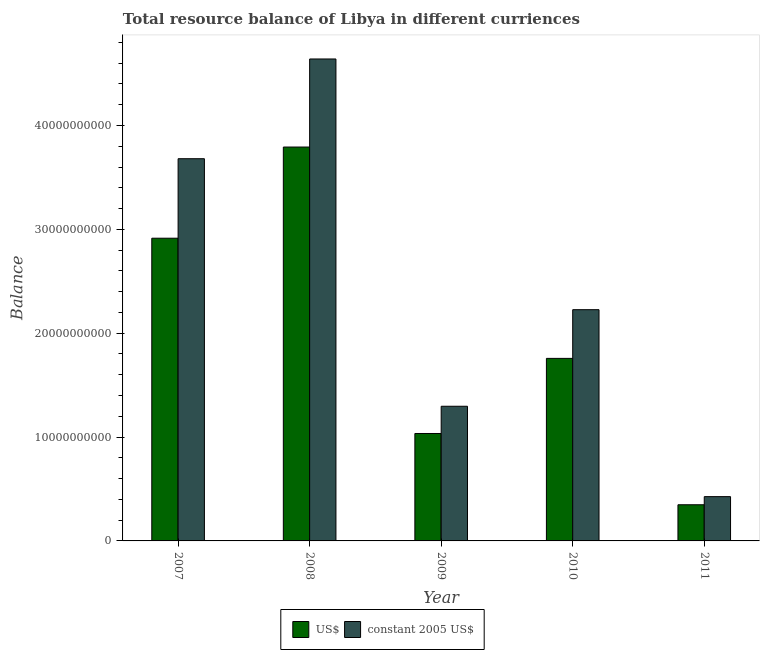How many groups of bars are there?
Offer a terse response. 5. Are the number of bars per tick equal to the number of legend labels?
Your answer should be very brief. Yes. Are the number of bars on each tick of the X-axis equal?
Offer a very short reply. Yes. What is the label of the 1st group of bars from the left?
Ensure brevity in your answer.  2007. What is the resource balance in us$ in 2010?
Offer a terse response. 1.76e+1. Across all years, what is the maximum resource balance in constant us$?
Make the answer very short. 4.64e+1. Across all years, what is the minimum resource balance in us$?
Give a very brief answer. 3.48e+09. In which year was the resource balance in us$ minimum?
Keep it short and to the point. 2011. What is the total resource balance in constant us$ in the graph?
Your answer should be compact. 1.23e+11. What is the difference between the resource balance in us$ in 2010 and that in 2011?
Provide a short and direct response. 1.41e+1. What is the difference between the resource balance in constant us$ in 2009 and the resource balance in us$ in 2008?
Offer a very short reply. -3.34e+1. What is the average resource balance in constant us$ per year?
Your answer should be compact. 2.45e+1. In the year 2008, what is the difference between the resource balance in constant us$ and resource balance in us$?
Your answer should be very brief. 0. In how many years, is the resource balance in constant us$ greater than 22000000000 units?
Offer a very short reply. 3. What is the ratio of the resource balance in constant us$ in 2009 to that in 2010?
Make the answer very short. 0.58. Is the resource balance in us$ in 2008 less than that in 2011?
Your answer should be very brief. No. Is the difference between the resource balance in constant us$ in 2007 and 2009 greater than the difference between the resource balance in us$ in 2007 and 2009?
Your answer should be very brief. No. What is the difference between the highest and the second highest resource balance in us$?
Keep it short and to the point. 8.78e+09. What is the difference between the highest and the lowest resource balance in us$?
Your answer should be very brief. 3.44e+1. What does the 1st bar from the left in 2007 represents?
Offer a very short reply. US$. What does the 1st bar from the right in 2010 represents?
Your answer should be very brief. Constant 2005 us$. How many years are there in the graph?
Your response must be concise. 5. Does the graph contain any zero values?
Your response must be concise. No. Does the graph contain grids?
Keep it short and to the point. No. Where does the legend appear in the graph?
Your answer should be compact. Bottom center. How are the legend labels stacked?
Ensure brevity in your answer.  Horizontal. What is the title of the graph?
Make the answer very short. Total resource balance of Libya in different curriences. What is the label or title of the Y-axis?
Make the answer very short. Balance. What is the Balance of US$ in 2007?
Offer a very short reply. 2.91e+1. What is the Balance in constant 2005 US$ in 2007?
Make the answer very short. 3.68e+1. What is the Balance in US$ in 2008?
Offer a very short reply. 3.79e+1. What is the Balance of constant 2005 US$ in 2008?
Your answer should be compact. 4.64e+1. What is the Balance in US$ in 2009?
Your answer should be very brief. 1.03e+1. What is the Balance in constant 2005 US$ in 2009?
Ensure brevity in your answer.  1.30e+1. What is the Balance of US$ in 2010?
Ensure brevity in your answer.  1.76e+1. What is the Balance of constant 2005 US$ in 2010?
Provide a short and direct response. 2.23e+1. What is the Balance of US$ in 2011?
Ensure brevity in your answer.  3.48e+09. What is the Balance in constant 2005 US$ in 2011?
Provide a short and direct response. 4.26e+09. Across all years, what is the maximum Balance of US$?
Your response must be concise. 3.79e+1. Across all years, what is the maximum Balance of constant 2005 US$?
Your answer should be compact. 4.64e+1. Across all years, what is the minimum Balance of US$?
Your response must be concise. 3.48e+09. Across all years, what is the minimum Balance in constant 2005 US$?
Keep it short and to the point. 4.26e+09. What is the total Balance of US$ in the graph?
Ensure brevity in your answer.  9.85e+1. What is the total Balance in constant 2005 US$ in the graph?
Offer a very short reply. 1.23e+11. What is the difference between the Balance in US$ in 2007 and that in 2008?
Keep it short and to the point. -8.78e+09. What is the difference between the Balance of constant 2005 US$ in 2007 and that in 2008?
Offer a very short reply. -9.60e+09. What is the difference between the Balance in US$ in 2007 and that in 2009?
Give a very brief answer. 1.88e+1. What is the difference between the Balance of constant 2005 US$ in 2007 and that in 2009?
Provide a short and direct response. 2.38e+1. What is the difference between the Balance of US$ in 2007 and that in 2010?
Keep it short and to the point. 1.16e+1. What is the difference between the Balance of constant 2005 US$ in 2007 and that in 2010?
Your answer should be very brief. 1.45e+1. What is the difference between the Balance of US$ in 2007 and that in 2011?
Provide a succinct answer. 2.57e+1. What is the difference between the Balance of constant 2005 US$ in 2007 and that in 2011?
Give a very brief answer. 3.25e+1. What is the difference between the Balance of US$ in 2008 and that in 2009?
Provide a succinct answer. 2.76e+1. What is the difference between the Balance of constant 2005 US$ in 2008 and that in 2009?
Ensure brevity in your answer.  3.34e+1. What is the difference between the Balance of US$ in 2008 and that in 2010?
Your answer should be compact. 2.04e+1. What is the difference between the Balance in constant 2005 US$ in 2008 and that in 2010?
Your response must be concise. 2.41e+1. What is the difference between the Balance in US$ in 2008 and that in 2011?
Offer a terse response. 3.44e+1. What is the difference between the Balance of constant 2005 US$ in 2008 and that in 2011?
Give a very brief answer. 4.21e+1. What is the difference between the Balance in US$ in 2009 and that in 2010?
Provide a succinct answer. -7.23e+09. What is the difference between the Balance of constant 2005 US$ in 2009 and that in 2010?
Offer a terse response. -9.30e+09. What is the difference between the Balance of US$ in 2009 and that in 2011?
Provide a succinct answer. 6.86e+09. What is the difference between the Balance of constant 2005 US$ in 2009 and that in 2011?
Your response must be concise. 8.70e+09. What is the difference between the Balance in US$ in 2010 and that in 2011?
Your response must be concise. 1.41e+1. What is the difference between the Balance of constant 2005 US$ in 2010 and that in 2011?
Your response must be concise. 1.80e+1. What is the difference between the Balance in US$ in 2007 and the Balance in constant 2005 US$ in 2008?
Keep it short and to the point. -1.73e+1. What is the difference between the Balance of US$ in 2007 and the Balance of constant 2005 US$ in 2009?
Ensure brevity in your answer.  1.62e+1. What is the difference between the Balance of US$ in 2007 and the Balance of constant 2005 US$ in 2010?
Make the answer very short. 6.88e+09. What is the difference between the Balance of US$ in 2007 and the Balance of constant 2005 US$ in 2011?
Offer a terse response. 2.49e+1. What is the difference between the Balance in US$ in 2008 and the Balance in constant 2005 US$ in 2009?
Give a very brief answer. 2.50e+1. What is the difference between the Balance of US$ in 2008 and the Balance of constant 2005 US$ in 2010?
Give a very brief answer. 1.57e+1. What is the difference between the Balance of US$ in 2008 and the Balance of constant 2005 US$ in 2011?
Offer a terse response. 3.37e+1. What is the difference between the Balance in US$ in 2009 and the Balance in constant 2005 US$ in 2010?
Your answer should be very brief. -1.19e+1. What is the difference between the Balance in US$ in 2009 and the Balance in constant 2005 US$ in 2011?
Your response must be concise. 6.08e+09. What is the difference between the Balance of US$ in 2010 and the Balance of constant 2005 US$ in 2011?
Make the answer very short. 1.33e+1. What is the average Balance of US$ per year?
Provide a short and direct response. 1.97e+1. What is the average Balance of constant 2005 US$ per year?
Give a very brief answer. 2.45e+1. In the year 2007, what is the difference between the Balance in US$ and Balance in constant 2005 US$?
Provide a succinct answer. -7.65e+09. In the year 2008, what is the difference between the Balance of US$ and Balance of constant 2005 US$?
Provide a short and direct response. -8.48e+09. In the year 2009, what is the difference between the Balance of US$ and Balance of constant 2005 US$?
Make the answer very short. -2.62e+09. In the year 2010, what is the difference between the Balance in US$ and Balance in constant 2005 US$?
Give a very brief answer. -4.69e+09. In the year 2011, what is the difference between the Balance of US$ and Balance of constant 2005 US$?
Give a very brief answer. -7.81e+08. What is the ratio of the Balance in US$ in 2007 to that in 2008?
Your answer should be compact. 0.77. What is the ratio of the Balance in constant 2005 US$ in 2007 to that in 2008?
Offer a very short reply. 0.79. What is the ratio of the Balance of US$ in 2007 to that in 2009?
Provide a short and direct response. 2.82. What is the ratio of the Balance of constant 2005 US$ in 2007 to that in 2009?
Give a very brief answer. 2.84. What is the ratio of the Balance of US$ in 2007 to that in 2010?
Provide a short and direct response. 1.66. What is the ratio of the Balance in constant 2005 US$ in 2007 to that in 2010?
Your response must be concise. 1.65. What is the ratio of the Balance of US$ in 2007 to that in 2011?
Keep it short and to the point. 8.37. What is the ratio of the Balance of constant 2005 US$ in 2007 to that in 2011?
Give a very brief answer. 8.63. What is the ratio of the Balance in US$ in 2008 to that in 2009?
Give a very brief answer. 3.67. What is the ratio of the Balance in constant 2005 US$ in 2008 to that in 2009?
Ensure brevity in your answer.  3.58. What is the ratio of the Balance in US$ in 2008 to that in 2010?
Offer a terse response. 2.16. What is the ratio of the Balance of constant 2005 US$ in 2008 to that in 2010?
Your answer should be very brief. 2.08. What is the ratio of the Balance in US$ in 2008 to that in 2011?
Your response must be concise. 10.89. What is the ratio of the Balance in constant 2005 US$ in 2008 to that in 2011?
Offer a terse response. 10.88. What is the ratio of the Balance of US$ in 2009 to that in 2010?
Your answer should be very brief. 0.59. What is the ratio of the Balance in constant 2005 US$ in 2009 to that in 2010?
Your response must be concise. 0.58. What is the ratio of the Balance in US$ in 2009 to that in 2011?
Ensure brevity in your answer.  2.97. What is the ratio of the Balance of constant 2005 US$ in 2009 to that in 2011?
Keep it short and to the point. 3.04. What is the ratio of the Balance in US$ in 2010 to that in 2011?
Make the answer very short. 5.05. What is the ratio of the Balance of constant 2005 US$ in 2010 to that in 2011?
Make the answer very short. 5.22. What is the difference between the highest and the second highest Balance in US$?
Your answer should be compact. 8.78e+09. What is the difference between the highest and the second highest Balance in constant 2005 US$?
Provide a short and direct response. 9.60e+09. What is the difference between the highest and the lowest Balance of US$?
Provide a succinct answer. 3.44e+1. What is the difference between the highest and the lowest Balance in constant 2005 US$?
Ensure brevity in your answer.  4.21e+1. 